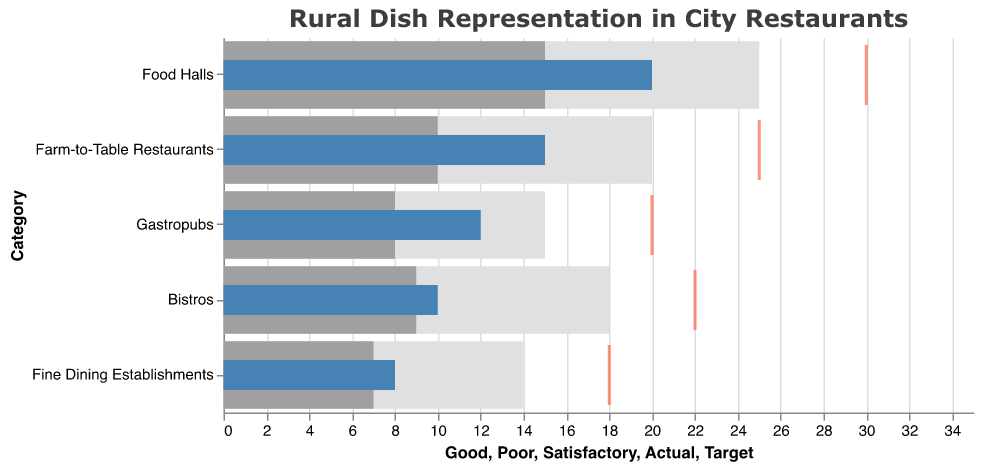What's the title of the chart? The title is displayed at the top of the chart and reads "Rural Dish Representation in City Restaurants".
Answer: Rural Dish Representation in City Restaurants What is the actual percentage of rural dishes featured in Gastropubs? The actual percentage is shown as a blue bar in the bullet chart for Gastropubs, which is labeled as 12.
Answer: 12 Which type of restaurant has the highest target percentage for rural dish representation? The target percentage is indicated by a red tick mark, and the highest value among these is for Food Halls, which is 30.
Answer: Food Halls How far below the target percentage is the actual percentage for Fine Dining Establishments? Subtract the actual percentage (8) from the target percentage (18) for Fine Dining Establishments: 18 - 8 = 10.
Answer: 10 Compare the actual percentages of rural dishes in Farm-to-Table Restaurants and Bistros. Which one is higher? The actual percentages are shown as blue bars: Farm-to-Table Restaurants have 15 and Bistros have 10. Therefore, Farm-to-Table Restaurants are higher.
Answer: Farm-to-Table Restaurants What is the range of the 'Good' threshold for Food Halls? The 'Good' threshold range is given in the data as starting from 0 to 25 for Food Halls.
Answer: 0 to 25 Which restaurant category has an actual percentage closest to its satisfactory threshold? The satisfactory threshold is represented by the gray bars. The category with an actual percentage (blue bar) closest to the satisfactory threshold value (gray bar) is Food Halls, as their actual is 20 and satisfactory is 15.
Answer: Food Halls What is the average actual percentage of rural dishes featured across all restaurant categories? Add all the actual percentages (15 + 12 + 8 + 10 + 20) and divide by the number of categories (5): (15 + 12 + 8 + 10 + 20) / 5 = 13.
Answer: 13 Which restaurant type is furthest from achieving its target percentage for rural dish representation? Calculate the differences between actual and target percentages for each category and find the largest value: 
Farm-to-Table Restaurants: 25 - 15 = 10
Gastropubs: 20 - 12 = 8
Fine Dining Establishments: 18 - 8 = 10
Bistros: 22 - 10 = 12
Food Halls: 30 - 20 = 10
Bistros have the largest difference, 12.
Answer: Bistros What does the color blue represent in the chart? The blue bars correspond to the actual percentages of rural dishes featured in each restaurant category.
Answer: Actual percentages 